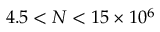<formula> <loc_0><loc_0><loc_500><loc_500>4 . 5 < N < 1 5 \times 1 0 ^ { 6 }</formula> 